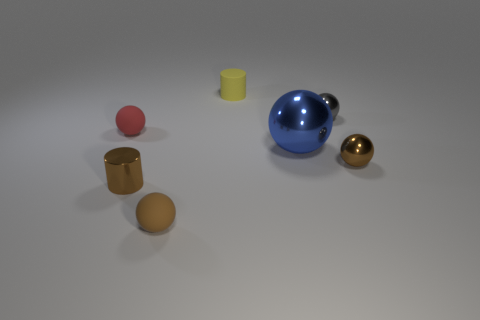What is the ball in front of the brown shiny object to the left of the rubber object in front of the big metal thing made of?
Provide a short and direct response. Rubber. There is a yellow rubber thing that is the same size as the red matte ball; what is its shape?
Ensure brevity in your answer.  Cylinder. How many things are either gray metal things or small balls that are on the left side of the small gray thing?
Provide a short and direct response. 3. Is the thing right of the gray object made of the same material as the small cylinder that is behind the blue sphere?
Offer a very short reply. No. How many brown things are either large spheres or small things?
Your response must be concise. 3. The brown metal cylinder has what size?
Offer a terse response. Small. Are there more matte cylinders to the right of the brown rubber thing than tiny purple cylinders?
Your answer should be very brief. Yes. What number of brown balls are to the right of the small brown matte sphere?
Offer a very short reply. 1. Is there a gray metallic sphere of the same size as the brown cylinder?
Offer a terse response. Yes. What color is the other large shiny thing that is the same shape as the red object?
Ensure brevity in your answer.  Blue. 